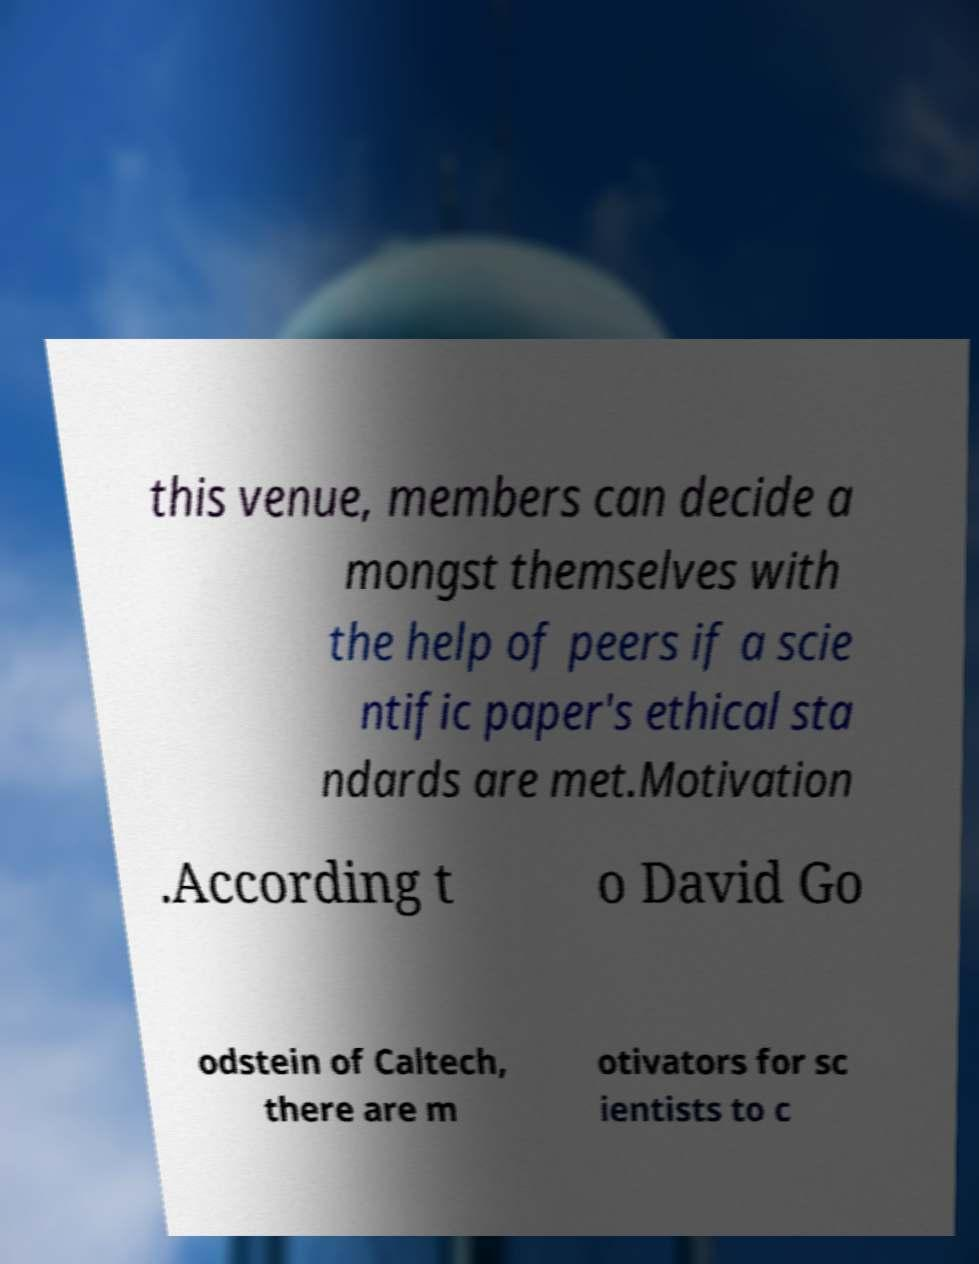For documentation purposes, I need the text within this image transcribed. Could you provide that? this venue, members can decide a mongst themselves with the help of peers if a scie ntific paper's ethical sta ndards are met.Motivation .According t o David Go odstein of Caltech, there are m otivators for sc ientists to c 